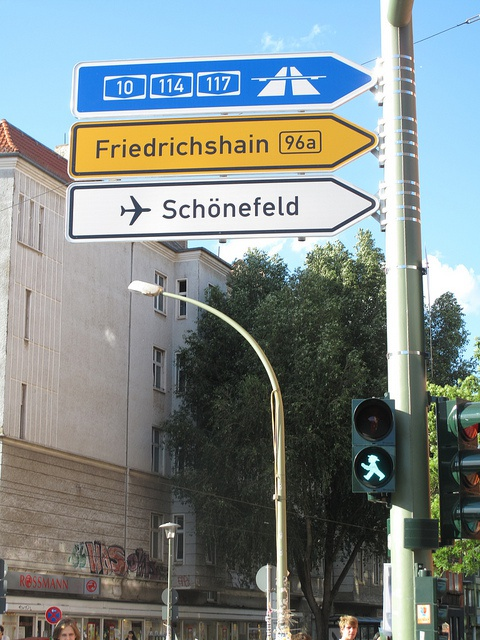Describe the objects in this image and their specific colors. I can see traffic light in lightblue, black, teal, and maroon tones, traffic light in lightblue, black, and teal tones, people in lightblue, gray, brown, and tan tones, people in lightblue, ivory, brown, and tan tones, and people in lightblue, black, and gray tones in this image. 